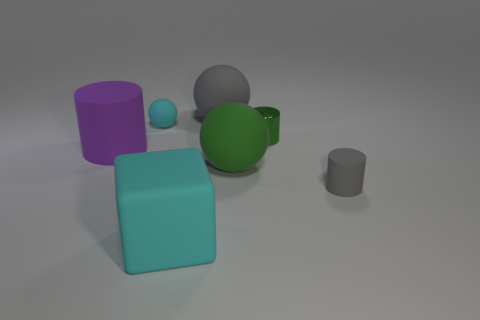How many other objects are there of the same material as the cyan ball?
Keep it short and to the point. 5. Does the gray thing in front of the purple thing have the same material as the small cylinder behind the tiny gray rubber object?
Your response must be concise. No. Are there any other things that have the same shape as the tiny cyan rubber object?
Provide a succinct answer. Yes. Is the material of the large purple thing the same as the small cylinder that is behind the large green matte ball?
Provide a short and direct response. No. There is a matte cylinder that is to the left of the small thing that is to the right of the metal thing in front of the cyan sphere; what color is it?
Offer a terse response. Purple. What is the shape of the gray matte thing that is the same size as the green cylinder?
Your answer should be very brief. Cylinder. Do the gray matte object that is to the left of the small green thing and the gray rubber thing that is in front of the small green shiny cylinder have the same size?
Your answer should be compact. No. There is a matte cylinder to the left of the small gray thing; how big is it?
Your answer should be very brief. Large. There is a small ball that is the same color as the large rubber cube; what material is it?
Ensure brevity in your answer.  Rubber. The other ball that is the same size as the green rubber ball is what color?
Provide a succinct answer. Gray. 